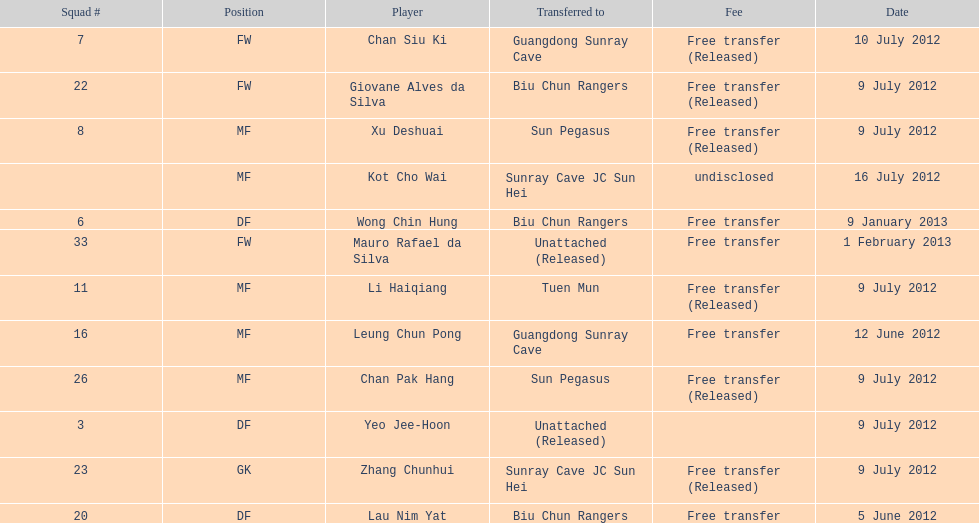Player transferred immediately before mauro rafael da silva Wong Chin Hung. 